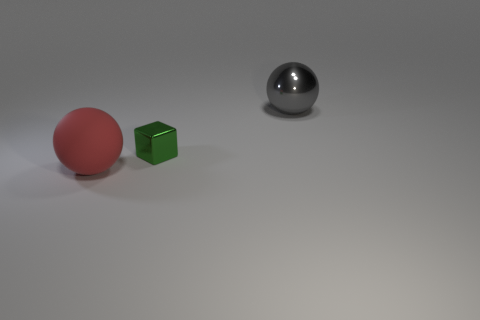There is a ball that is in front of the ball behind the green metal object; what is its color?
Offer a terse response. Red. There is a thing that is on the right side of the big red matte sphere and on the left side of the gray thing; what material is it?
Your answer should be very brief. Metal. Are there any large blue objects of the same shape as the tiny green metal object?
Offer a very short reply. No. Does the big thing behind the big red ball have the same shape as the large red matte thing?
Provide a succinct answer. Yes. How many big objects are both on the right side of the tiny green cube and in front of the tiny green block?
Give a very brief answer. 0. What is the shape of the large object that is on the left side of the gray sphere?
Provide a succinct answer. Sphere. How many objects have the same material as the green block?
Your answer should be compact. 1. There is a small shiny object; is it the same shape as the object in front of the tiny object?
Offer a terse response. No. Is there a small green shiny cube that is in front of the small metallic block that is to the right of the large thing that is to the left of the big gray sphere?
Provide a succinct answer. No. How big is the metallic object right of the green metal thing?
Offer a very short reply. Large. 